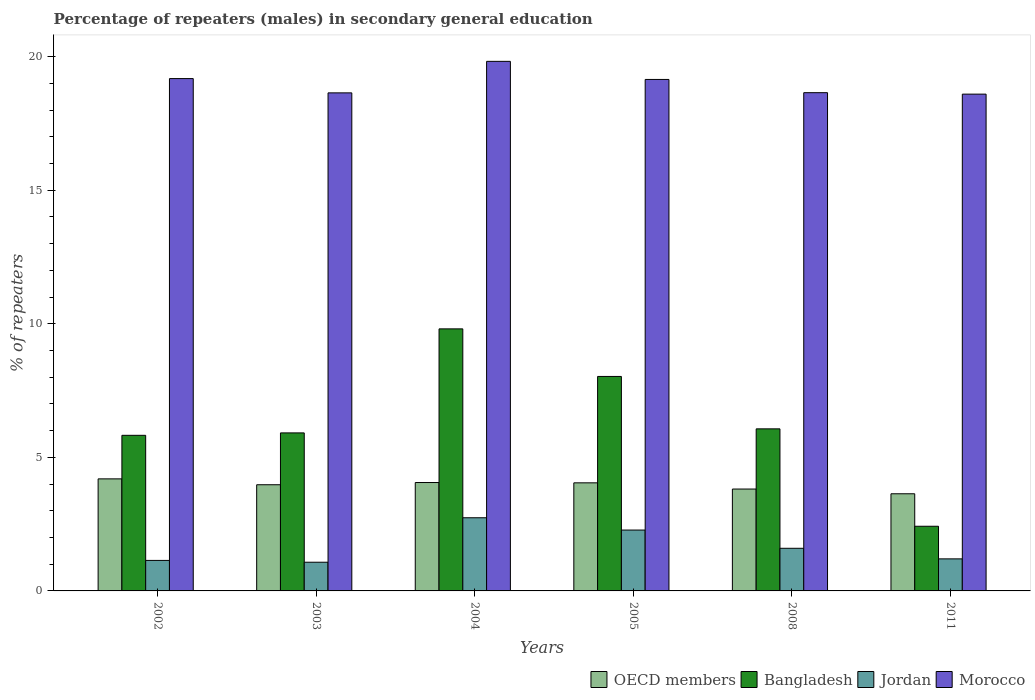How many groups of bars are there?
Give a very brief answer. 6. Are the number of bars per tick equal to the number of legend labels?
Keep it short and to the point. Yes. Are the number of bars on each tick of the X-axis equal?
Keep it short and to the point. Yes. How many bars are there on the 3rd tick from the left?
Provide a succinct answer. 4. What is the label of the 2nd group of bars from the left?
Offer a terse response. 2003. What is the percentage of male repeaters in OECD members in 2011?
Give a very brief answer. 3.64. Across all years, what is the maximum percentage of male repeaters in Morocco?
Your answer should be compact. 19.82. Across all years, what is the minimum percentage of male repeaters in Morocco?
Provide a succinct answer. 18.6. What is the total percentage of male repeaters in Bangladesh in the graph?
Provide a short and direct response. 38.07. What is the difference between the percentage of male repeaters in OECD members in 2002 and that in 2008?
Give a very brief answer. 0.38. What is the difference between the percentage of male repeaters in OECD members in 2003 and the percentage of male repeaters in Morocco in 2002?
Keep it short and to the point. -15.2. What is the average percentage of male repeaters in Morocco per year?
Make the answer very short. 19.01. In the year 2002, what is the difference between the percentage of male repeaters in OECD members and percentage of male repeaters in Morocco?
Offer a terse response. -14.98. What is the ratio of the percentage of male repeaters in Morocco in 2004 to that in 2005?
Offer a very short reply. 1.04. Is the difference between the percentage of male repeaters in OECD members in 2002 and 2008 greater than the difference between the percentage of male repeaters in Morocco in 2002 and 2008?
Provide a succinct answer. No. What is the difference between the highest and the second highest percentage of male repeaters in OECD members?
Offer a very short reply. 0.14. What is the difference between the highest and the lowest percentage of male repeaters in Jordan?
Your response must be concise. 1.66. In how many years, is the percentage of male repeaters in OECD members greater than the average percentage of male repeaters in OECD members taken over all years?
Keep it short and to the point. 4. Is the sum of the percentage of male repeaters in Jordan in 2008 and 2011 greater than the maximum percentage of male repeaters in OECD members across all years?
Offer a very short reply. No. What is the difference between two consecutive major ticks on the Y-axis?
Your answer should be compact. 5. Does the graph contain grids?
Keep it short and to the point. No. Where does the legend appear in the graph?
Provide a short and direct response. Bottom right. How many legend labels are there?
Provide a short and direct response. 4. What is the title of the graph?
Your answer should be very brief. Percentage of repeaters (males) in secondary general education. What is the label or title of the X-axis?
Provide a short and direct response. Years. What is the label or title of the Y-axis?
Give a very brief answer. % of repeaters. What is the % of repeaters in OECD members in 2002?
Your response must be concise. 4.19. What is the % of repeaters of Bangladesh in 2002?
Keep it short and to the point. 5.82. What is the % of repeaters in Jordan in 2002?
Provide a succinct answer. 1.14. What is the % of repeaters in Morocco in 2002?
Give a very brief answer. 19.18. What is the % of repeaters in OECD members in 2003?
Provide a short and direct response. 3.97. What is the % of repeaters in Bangladesh in 2003?
Offer a terse response. 5.92. What is the % of repeaters of Jordan in 2003?
Keep it short and to the point. 1.07. What is the % of repeaters of Morocco in 2003?
Make the answer very short. 18.64. What is the % of repeaters of OECD members in 2004?
Your response must be concise. 4.06. What is the % of repeaters of Bangladesh in 2004?
Offer a very short reply. 9.81. What is the % of repeaters of Jordan in 2004?
Your response must be concise. 2.74. What is the % of repeaters in Morocco in 2004?
Your answer should be compact. 19.82. What is the % of repeaters of OECD members in 2005?
Ensure brevity in your answer.  4.05. What is the % of repeaters in Bangladesh in 2005?
Your answer should be very brief. 8.03. What is the % of repeaters in Jordan in 2005?
Offer a terse response. 2.28. What is the % of repeaters of Morocco in 2005?
Provide a short and direct response. 19.15. What is the % of repeaters in OECD members in 2008?
Ensure brevity in your answer.  3.81. What is the % of repeaters of Bangladesh in 2008?
Provide a short and direct response. 6.07. What is the % of repeaters in Jordan in 2008?
Your answer should be very brief. 1.6. What is the % of repeaters in Morocco in 2008?
Offer a terse response. 18.65. What is the % of repeaters in OECD members in 2011?
Give a very brief answer. 3.64. What is the % of repeaters in Bangladesh in 2011?
Keep it short and to the point. 2.42. What is the % of repeaters of Jordan in 2011?
Keep it short and to the point. 1.2. What is the % of repeaters of Morocco in 2011?
Give a very brief answer. 18.6. Across all years, what is the maximum % of repeaters of OECD members?
Your response must be concise. 4.19. Across all years, what is the maximum % of repeaters of Bangladesh?
Make the answer very short. 9.81. Across all years, what is the maximum % of repeaters of Jordan?
Make the answer very short. 2.74. Across all years, what is the maximum % of repeaters of Morocco?
Give a very brief answer. 19.82. Across all years, what is the minimum % of repeaters in OECD members?
Make the answer very short. 3.64. Across all years, what is the minimum % of repeaters of Bangladesh?
Offer a terse response. 2.42. Across all years, what is the minimum % of repeaters in Jordan?
Provide a succinct answer. 1.07. Across all years, what is the minimum % of repeaters in Morocco?
Keep it short and to the point. 18.6. What is the total % of repeaters in OECD members in the graph?
Provide a succinct answer. 23.72. What is the total % of repeaters of Bangladesh in the graph?
Offer a very short reply. 38.07. What is the total % of repeaters of Jordan in the graph?
Provide a short and direct response. 10.03. What is the total % of repeaters of Morocco in the graph?
Keep it short and to the point. 114.04. What is the difference between the % of repeaters of OECD members in 2002 and that in 2003?
Your answer should be very brief. 0.22. What is the difference between the % of repeaters in Bangladesh in 2002 and that in 2003?
Give a very brief answer. -0.09. What is the difference between the % of repeaters in Jordan in 2002 and that in 2003?
Your response must be concise. 0.07. What is the difference between the % of repeaters in Morocco in 2002 and that in 2003?
Your response must be concise. 0.53. What is the difference between the % of repeaters in OECD members in 2002 and that in 2004?
Your answer should be compact. 0.14. What is the difference between the % of repeaters in Bangladesh in 2002 and that in 2004?
Provide a short and direct response. -3.98. What is the difference between the % of repeaters of Jordan in 2002 and that in 2004?
Your response must be concise. -1.6. What is the difference between the % of repeaters in Morocco in 2002 and that in 2004?
Ensure brevity in your answer.  -0.65. What is the difference between the % of repeaters in OECD members in 2002 and that in 2005?
Your answer should be compact. 0.15. What is the difference between the % of repeaters in Bangladesh in 2002 and that in 2005?
Make the answer very short. -2.2. What is the difference between the % of repeaters in Jordan in 2002 and that in 2005?
Your answer should be compact. -1.14. What is the difference between the % of repeaters of Morocco in 2002 and that in 2005?
Ensure brevity in your answer.  0.03. What is the difference between the % of repeaters in OECD members in 2002 and that in 2008?
Offer a very short reply. 0.38. What is the difference between the % of repeaters of Bangladesh in 2002 and that in 2008?
Your answer should be very brief. -0.24. What is the difference between the % of repeaters of Jordan in 2002 and that in 2008?
Your response must be concise. -0.45. What is the difference between the % of repeaters of Morocco in 2002 and that in 2008?
Give a very brief answer. 0.53. What is the difference between the % of repeaters of OECD members in 2002 and that in 2011?
Make the answer very short. 0.56. What is the difference between the % of repeaters of Bangladesh in 2002 and that in 2011?
Make the answer very short. 3.4. What is the difference between the % of repeaters of Jordan in 2002 and that in 2011?
Your answer should be very brief. -0.06. What is the difference between the % of repeaters in Morocco in 2002 and that in 2011?
Ensure brevity in your answer.  0.58. What is the difference between the % of repeaters in OECD members in 2003 and that in 2004?
Give a very brief answer. -0.08. What is the difference between the % of repeaters of Bangladesh in 2003 and that in 2004?
Your answer should be compact. -3.89. What is the difference between the % of repeaters in Jordan in 2003 and that in 2004?
Your answer should be compact. -1.66. What is the difference between the % of repeaters of Morocco in 2003 and that in 2004?
Give a very brief answer. -1.18. What is the difference between the % of repeaters of OECD members in 2003 and that in 2005?
Ensure brevity in your answer.  -0.07. What is the difference between the % of repeaters in Bangladesh in 2003 and that in 2005?
Your answer should be compact. -2.11. What is the difference between the % of repeaters in Jordan in 2003 and that in 2005?
Your answer should be compact. -1.2. What is the difference between the % of repeaters of Morocco in 2003 and that in 2005?
Ensure brevity in your answer.  -0.5. What is the difference between the % of repeaters of OECD members in 2003 and that in 2008?
Your answer should be compact. 0.16. What is the difference between the % of repeaters in Bangladesh in 2003 and that in 2008?
Your answer should be very brief. -0.15. What is the difference between the % of repeaters in Jordan in 2003 and that in 2008?
Provide a succinct answer. -0.52. What is the difference between the % of repeaters of Morocco in 2003 and that in 2008?
Provide a short and direct response. -0.01. What is the difference between the % of repeaters in OECD members in 2003 and that in 2011?
Give a very brief answer. 0.34. What is the difference between the % of repeaters of Bangladesh in 2003 and that in 2011?
Keep it short and to the point. 3.5. What is the difference between the % of repeaters of Jordan in 2003 and that in 2011?
Make the answer very short. -0.13. What is the difference between the % of repeaters of Morocco in 2003 and that in 2011?
Your answer should be compact. 0.05. What is the difference between the % of repeaters of OECD members in 2004 and that in 2005?
Your answer should be very brief. 0.01. What is the difference between the % of repeaters in Bangladesh in 2004 and that in 2005?
Ensure brevity in your answer.  1.78. What is the difference between the % of repeaters of Jordan in 2004 and that in 2005?
Keep it short and to the point. 0.46. What is the difference between the % of repeaters of Morocco in 2004 and that in 2005?
Your response must be concise. 0.68. What is the difference between the % of repeaters of OECD members in 2004 and that in 2008?
Ensure brevity in your answer.  0.24. What is the difference between the % of repeaters of Bangladesh in 2004 and that in 2008?
Your response must be concise. 3.74. What is the difference between the % of repeaters in Jordan in 2004 and that in 2008?
Keep it short and to the point. 1.14. What is the difference between the % of repeaters in Morocco in 2004 and that in 2008?
Provide a short and direct response. 1.17. What is the difference between the % of repeaters in OECD members in 2004 and that in 2011?
Give a very brief answer. 0.42. What is the difference between the % of repeaters in Bangladesh in 2004 and that in 2011?
Provide a succinct answer. 7.39. What is the difference between the % of repeaters of Jordan in 2004 and that in 2011?
Give a very brief answer. 1.54. What is the difference between the % of repeaters in Morocco in 2004 and that in 2011?
Offer a terse response. 1.23. What is the difference between the % of repeaters of OECD members in 2005 and that in 2008?
Offer a terse response. 0.23. What is the difference between the % of repeaters of Bangladesh in 2005 and that in 2008?
Provide a succinct answer. 1.96. What is the difference between the % of repeaters of Jordan in 2005 and that in 2008?
Make the answer very short. 0.68. What is the difference between the % of repeaters in Morocco in 2005 and that in 2008?
Give a very brief answer. 0.5. What is the difference between the % of repeaters of OECD members in 2005 and that in 2011?
Your answer should be very brief. 0.41. What is the difference between the % of repeaters in Bangladesh in 2005 and that in 2011?
Your answer should be compact. 5.61. What is the difference between the % of repeaters in Jordan in 2005 and that in 2011?
Your answer should be very brief. 1.08. What is the difference between the % of repeaters of Morocco in 2005 and that in 2011?
Your answer should be compact. 0.55. What is the difference between the % of repeaters of OECD members in 2008 and that in 2011?
Keep it short and to the point. 0.18. What is the difference between the % of repeaters in Bangladesh in 2008 and that in 2011?
Your answer should be compact. 3.65. What is the difference between the % of repeaters in Jordan in 2008 and that in 2011?
Your answer should be compact. 0.4. What is the difference between the % of repeaters in Morocco in 2008 and that in 2011?
Give a very brief answer. 0.05. What is the difference between the % of repeaters in OECD members in 2002 and the % of repeaters in Bangladesh in 2003?
Ensure brevity in your answer.  -1.72. What is the difference between the % of repeaters of OECD members in 2002 and the % of repeaters of Jordan in 2003?
Keep it short and to the point. 3.12. What is the difference between the % of repeaters of OECD members in 2002 and the % of repeaters of Morocco in 2003?
Provide a short and direct response. -14.45. What is the difference between the % of repeaters in Bangladesh in 2002 and the % of repeaters in Jordan in 2003?
Your answer should be very brief. 4.75. What is the difference between the % of repeaters of Bangladesh in 2002 and the % of repeaters of Morocco in 2003?
Offer a very short reply. -12.82. What is the difference between the % of repeaters of Jordan in 2002 and the % of repeaters of Morocco in 2003?
Your answer should be very brief. -17.5. What is the difference between the % of repeaters of OECD members in 2002 and the % of repeaters of Bangladesh in 2004?
Provide a short and direct response. -5.61. What is the difference between the % of repeaters of OECD members in 2002 and the % of repeaters of Jordan in 2004?
Your response must be concise. 1.46. What is the difference between the % of repeaters in OECD members in 2002 and the % of repeaters in Morocco in 2004?
Your response must be concise. -15.63. What is the difference between the % of repeaters of Bangladesh in 2002 and the % of repeaters of Jordan in 2004?
Offer a terse response. 3.09. What is the difference between the % of repeaters of Bangladesh in 2002 and the % of repeaters of Morocco in 2004?
Offer a very short reply. -14. What is the difference between the % of repeaters in Jordan in 2002 and the % of repeaters in Morocco in 2004?
Keep it short and to the point. -18.68. What is the difference between the % of repeaters of OECD members in 2002 and the % of repeaters of Bangladesh in 2005?
Offer a very short reply. -3.83. What is the difference between the % of repeaters of OECD members in 2002 and the % of repeaters of Jordan in 2005?
Your answer should be very brief. 1.92. What is the difference between the % of repeaters of OECD members in 2002 and the % of repeaters of Morocco in 2005?
Provide a succinct answer. -14.95. What is the difference between the % of repeaters of Bangladesh in 2002 and the % of repeaters of Jordan in 2005?
Give a very brief answer. 3.55. What is the difference between the % of repeaters in Bangladesh in 2002 and the % of repeaters in Morocco in 2005?
Keep it short and to the point. -13.32. What is the difference between the % of repeaters in Jordan in 2002 and the % of repeaters in Morocco in 2005?
Provide a succinct answer. -18. What is the difference between the % of repeaters in OECD members in 2002 and the % of repeaters in Bangladesh in 2008?
Your answer should be very brief. -1.87. What is the difference between the % of repeaters in OECD members in 2002 and the % of repeaters in Jordan in 2008?
Your answer should be compact. 2.6. What is the difference between the % of repeaters of OECD members in 2002 and the % of repeaters of Morocco in 2008?
Your answer should be compact. -14.46. What is the difference between the % of repeaters in Bangladesh in 2002 and the % of repeaters in Jordan in 2008?
Your answer should be compact. 4.23. What is the difference between the % of repeaters of Bangladesh in 2002 and the % of repeaters of Morocco in 2008?
Offer a terse response. -12.83. What is the difference between the % of repeaters in Jordan in 2002 and the % of repeaters in Morocco in 2008?
Provide a short and direct response. -17.51. What is the difference between the % of repeaters in OECD members in 2002 and the % of repeaters in Bangladesh in 2011?
Offer a terse response. 1.77. What is the difference between the % of repeaters of OECD members in 2002 and the % of repeaters of Jordan in 2011?
Offer a terse response. 3. What is the difference between the % of repeaters in OECD members in 2002 and the % of repeaters in Morocco in 2011?
Provide a succinct answer. -14.4. What is the difference between the % of repeaters of Bangladesh in 2002 and the % of repeaters of Jordan in 2011?
Make the answer very short. 4.63. What is the difference between the % of repeaters in Bangladesh in 2002 and the % of repeaters in Morocco in 2011?
Your answer should be very brief. -12.77. What is the difference between the % of repeaters in Jordan in 2002 and the % of repeaters in Morocco in 2011?
Provide a short and direct response. -17.46. What is the difference between the % of repeaters in OECD members in 2003 and the % of repeaters in Bangladesh in 2004?
Provide a succinct answer. -5.83. What is the difference between the % of repeaters in OECD members in 2003 and the % of repeaters in Jordan in 2004?
Your response must be concise. 1.24. What is the difference between the % of repeaters of OECD members in 2003 and the % of repeaters of Morocco in 2004?
Ensure brevity in your answer.  -15.85. What is the difference between the % of repeaters in Bangladesh in 2003 and the % of repeaters in Jordan in 2004?
Keep it short and to the point. 3.18. What is the difference between the % of repeaters in Bangladesh in 2003 and the % of repeaters in Morocco in 2004?
Your answer should be very brief. -13.91. What is the difference between the % of repeaters of Jordan in 2003 and the % of repeaters of Morocco in 2004?
Give a very brief answer. -18.75. What is the difference between the % of repeaters of OECD members in 2003 and the % of repeaters of Bangladesh in 2005?
Provide a short and direct response. -4.05. What is the difference between the % of repeaters of OECD members in 2003 and the % of repeaters of Jordan in 2005?
Your response must be concise. 1.7. What is the difference between the % of repeaters in OECD members in 2003 and the % of repeaters in Morocco in 2005?
Offer a very short reply. -15.17. What is the difference between the % of repeaters of Bangladesh in 2003 and the % of repeaters of Jordan in 2005?
Make the answer very short. 3.64. What is the difference between the % of repeaters of Bangladesh in 2003 and the % of repeaters of Morocco in 2005?
Provide a succinct answer. -13.23. What is the difference between the % of repeaters of Jordan in 2003 and the % of repeaters of Morocco in 2005?
Provide a short and direct response. -18.07. What is the difference between the % of repeaters of OECD members in 2003 and the % of repeaters of Bangladesh in 2008?
Your answer should be very brief. -2.09. What is the difference between the % of repeaters of OECD members in 2003 and the % of repeaters of Jordan in 2008?
Your response must be concise. 2.38. What is the difference between the % of repeaters in OECD members in 2003 and the % of repeaters in Morocco in 2008?
Your response must be concise. -14.68. What is the difference between the % of repeaters of Bangladesh in 2003 and the % of repeaters of Jordan in 2008?
Provide a short and direct response. 4.32. What is the difference between the % of repeaters in Bangladesh in 2003 and the % of repeaters in Morocco in 2008?
Offer a terse response. -12.74. What is the difference between the % of repeaters of Jordan in 2003 and the % of repeaters of Morocco in 2008?
Your answer should be very brief. -17.58. What is the difference between the % of repeaters in OECD members in 2003 and the % of repeaters in Bangladesh in 2011?
Offer a terse response. 1.55. What is the difference between the % of repeaters in OECD members in 2003 and the % of repeaters in Jordan in 2011?
Your response must be concise. 2.78. What is the difference between the % of repeaters of OECD members in 2003 and the % of repeaters of Morocco in 2011?
Offer a very short reply. -14.62. What is the difference between the % of repeaters in Bangladesh in 2003 and the % of repeaters in Jordan in 2011?
Your answer should be very brief. 4.72. What is the difference between the % of repeaters of Bangladesh in 2003 and the % of repeaters of Morocco in 2011?
Your answer should be compact. -12.68. What is the difference between the % of repeaters in Jordan in 2003 and the % of repeaters in Morocco in 2011?
Ensure brevity in your answer.  -17.52. What is the difference between the % of repeaters of OECD members in 2004 and the % of repeaters of Bangladesh in 2005?
Give a very brief answer. -3.97. What is the difference between the % of repeaters in OECD members in 2004 and the % of repeaters in Jordan in 2005?
Provide a succinct answer. 1.78. What is the difference between the % of repeaters of OECD members in 2004 and the % of repeaters of Morocco in 2005?
Provide a short and direct response. -15.09. What is the difference between the % of repeaters in Bangladesh in 2004 and the % of repeaters in Jordan in 2005?
Offer a terse response. 7.53. What is the difference between the % of repeaters in Bangladesh in 2004 and the % of repeaters in Morocco in 2005?
Your answer should be very brief. -9.34. What is the difference between the % of repeaters in Jordan in 2004 and the % of repeaters in Morocco in 2005?
Your answer should be very brief. -16.41. What is the difference between the % of repeaters of OECD members in 2004 and the % of repeaters of Bangladesh in 2008?
Keep it short and to the point. -2.01. What is the difference between the % of repeaters in OECD members in 2004 and the % of repeaters in Jordan in 2008?
Keep it short and to the point. 2.46. What is the difference between the % of repeaters of OECD members in 2004 and the % of repeaters of Morocco in 2008?
Your answer should be compact. -14.59. What is the difference between the % of repeaters of Bangladesh in 2004 and the % of repeaters of Jordan in 2008?
Offer a very short reply. 8.21. What is the difference between the % of repeaters of Bangladesh in 2004 and the % of repeaters of Morocco in 2008?
Give a very brief answer. -8.84. What is the difference between the % of repeaters of Jordan in 2004 and the % of repeaters of Morocco in 2008?
Keep it short and to the point. -15.91. What is the difference between the % of repeaters of OECD members in 2004 and the % of repeaters of Bangladesh in 2011?
Offer a very short reply. 1.64. What is the difference between the % of repeaters of OECD members in 2004 and the % of repeaters of Jordan in 2011?
Your answer should be compact. 2.86. What is the difference between the % of repeaters of OECD members in 2004 and the % of repeaters of Morocco in 2011?
Make the answer very short. -14.54. What is the difference between the % of repeaters of Bangladesh in 2004 and the % of repeaters of Jordan in 2011?
Keep it short and to the point. 8.61. What is the difference between the % of repeaters in Bangladesh in 2004 and the % of repeaters in Morocco in 2011?
Offer a very short reply. -8.79. What is the difference between the % of repeaters in Jordan in 2004 and the % of repeaters in Morocco in 2011?
Make the answer very short. -15.86. What is the difference between the % of repeaters in OECD members in 2005 and the % of repeaters in Bangladesh in 2008?
Offer a very short reply. -2.02. What is the difference between the % of repeaters of OECD members in 2005 and the % of repeaters of Jordan in 2008?
Offer a very short reply. 2.45. What is the difference between the % of repeaters of OECD members in 2005 and the % of repeaters of Morocco in 2008?
Make the answer very short. -14.6. What is the difference between the % of repeaters in Bangladesh in 2005 and the % of repeaters in Jordan in 2008?
Keep it short and to the point. 6.43. What is the difference between the % of repeaters of Bangladesh in 2005 and the % of repeaters of Morocco in 2008?
Keep it short and to the point. -10.62. What is the difference between the % of repeaters in Jordan in 2005 and the % of repeaters in Morocco in 2008?
Your response must be concise. -16.37. What is the difference between the % of repeaters in OECD members in 2005 and the % of repeaters in Bangladesh in 2011?
Your answer should be very brief. 1.63. What is the difference between the % of repeaters in OECD members in 2005 and the % of repeaters in Jordan in 2011?
Ensure brevity in your answer.  2.85. What is the difference between the % of repeaters of OECD members in 2005 and the % of repeaters of Morocco in 2011?
Your answer should be very brief. -14.55. What is the difference between the % of repeaters in Bangladesh in 2005 and the % of repeaters in Jordan in 2011?
Provide a short and direct response. 6.83. What is the difference between the % of repeaters in Bangladesh in 2005 and the % of repeaters in Morocco in 2011?
Your response must be concise. -10.57. What is the difference between the % of repeaters of Jordan in 2005 and the % of repeaters of Morocco in 2011?
Make the answer very short. -16.32. What is the difference between the % of repeaters of OECD members in 2008 and the % of repeaters of Bangladesh in 2011?
Provide a short and direct response. 1.39. What is the difference between the % of repeaters of OECD members in 2008 and the % of repeaters of Jordan in 2011?
Your answer should be compact. 2.61. What is the difference between the % of repeaters in OECD members in 2008 and the % of repeaters in Morocco in 2011?
Make the answer very short. -14.78. What is the difference between the % of repeaters in Bangladesh in 2008 and the % of repeaters in Jordan in 2011?
Give a very brief answer. 4.87. What is the difference between the % of repeaters in Bangladesh in 2008 and the % of repeaters in Morocco in 2011?
Your answer should be very brief. -12.53. What is the difference between the % of repeaters of Jordan in 2008 and the % of repeaters of Morocco in 2011?
Provide a short and direct response. -17. What is the average % of repeaters in OECD members per year?
Make the answer very short. 3.95. What is the average % of repeaters in Bangladesh per year?
Provide a short and direct response. 6.34. What is the average % of repeaters of Jordan per year?
Ensure brevity in your answer.  1.67. What is the average % of repeaters in Morocco per year?
Keep it short and to the point. 19.01. In the year 2002, what is the difference between the % of repeaters in OECD members and % of repeaters in Bangladesh?
Offer a very short reply. -1.63. In the year 2002, what is the difference between the % of repeaters in OECD members and % of repeaters in Jordan?
Keep it short and to the point. 3.05. In the year 2002, what is the difference between the % of repeaters in OECD members and % of repeaters in Morocco?
Give a very brief answer. -14.98. In the year 2002, what is the difference between the % of repeaters of Bangladesh and % of repeaters of Jordan?
Provide a short and direct response. 4.68. In the year 2002, what is the difference between the % of repeaters in Bangladesh and % of repeaters in Morocco?
Offer a terse response. -13.35. In the year 2002, what is the difference between the % of repeaters in Jordan and % of repeaters in Morocco?
Offer a terse response. -18.04. In the year 2003, what is the difference between the % of repeaters in OECD members and % of repeaters in Bangladesh?
Make the answer very short. -1.94. In the year 2003, what is the difference between the % of repeaters in OECD members and % of repeaters in Jordan?
Make the answer very short. 2.9. In the year 2003, what is the difference between the % of repeaters of OECD members and % of repeaters of Morocco?
Provide a short and direct response. -14.67. In the year 2003, what is the difference between the % of repeaters of Bangladesh and % of repeaters of Jordan?
Your answer should be compact. 4.84. In the year 2003, what is the difference between the % of repeaters of Bangladesh and % of repeaters of Morocco?
Your answer should be compact. -12.73. In the year 2003, what is the difference between the % of repeaters of Jordan and % of repeaters of Morocco?
Offer a very short reply. -17.57. In the year 2004, what is the difference between the % of repeaters of OECD members and % of repeaters of Bangladesh?
Your answer should be compact. -5.75. In the year 2004, what is the difference between the % of repeaters in OECD members and % of repeaters in Jordan?
Keep it short and to the point. 1.32. In the year 2004, what is the difference between the % of repeaters in OECD members and % of repeaters in Morocco?
Keep it short and to the point. -15.77. In the year 2004, what is the difference between the % of repeaters of Bangladesh and % of repeaters of Jordan?
Give a very brief answer. 7.07. In the year 2004, what is the difference between the % of repeaters of Bangladesh and % of repeaters of Morocco?
Make the answer very short. -10.01. In the year 2004, what is the difference between the % of repeaters in Jordan and % of repeaters in Morocco?
Ensure brevity in your answer.  -17.09. In the year 2005, what is the difference between the % of repeaters in OECD members and % of repeaters in Bangladesh?
Your answer should be very brief. -3.98. In the year 2005, what is the difference between the % of repeaters in OECD members and % of repeaters in Jordan?
Offer a terse response. 1.77. In the year 2005, what is the difference between the % of repeaters of OECD members and % of repeaters of Morocco?
Offer a terse response. -15.1. In the year 2005, what is the difference between the % of repeaters of Bangladesh and % of repeaters of Jordan?
Provide a succinct answer. 5.75. In the year 2005, what is the difference between the % of repeaters in Bangladesh and % of repeaters in Morocco?
Make the answer very short. -11.12. In the year 2005, what is the difference between the % of repeaters in Jordan and % of repeaters in Morocco?
Your answer should be compact. -16.87. In the year 2008, what is the difference between the % of repeaters of OECD members and % of repeaters of Bangladesh?
Keep it short and to the point. -2.25. In the year 2008, what is the difference between the % of repeaters of OECD members and % of repeaters of Jordan?
Provide a succinct answer. 2.22. In the year 2008, what is the difference between the % of repeaters of OECD members and % of repeaters of Morocco?
Keep it short and to the point. -14.84. In the year 2008, what is the difference between the % of repeaters of Bangladesh and % of repeaters of Jordan?
Make the answer very short. 4.47. In the year 2008, what is the difference between the % of repeaters of Bangladesh and % of repeaters of Morocco?
Make the answer very short. -12.58. In the year 2008, what is the difference between the % of repeaters in Jordan and % of repeaters in Morocco?
Your answer should be compact. -17.06. In the year 2011, what is the difference between the % of repeaters of OECD members and % of repeaters of Bangladesh?
Offer a terse response. 1.22. In the year 2011, what is the difference between the % of repeaters in OECD members and % of repeaters in Jordan?
Your answer should be very brief. 2.44. In the year 2011, what is the difference between the % of repeaters of OECD members and % of repeaters of Morocco?
Keep it short and to the point. -14.96. In the year 2011, what is the difference between the % of repeaters of Bangladesh and % of repeaters of Jordan?
Your answer should be very brief. 1.22. In the year 2011, what is the difference between the % of repeaters in Bangladesh and % of repeaters in Morocco?
Make the answer very short. -16.18. In the year 2011, what is the difference between the % of repeaters in Jordan and % of repeaters in Morocco?
Your response must be concise. -17.4. What is the ratio of the % of repeaters of OECD members in 2002 to that in 2003?
Ensure brevity in your answer.  1.06. What is the ratio of the % of repeaters in Bangladesh in 2002 to that in 2003?
Keep it short and to the point. 0.98. What is the ratio of the % of repeaters in Jordan in 2002 to that in 2003?
Your answer should be compact. 1.06. What is the ratio of the % of repeaters in Morocco in 2002 to that in 2003?
Offer a terse response. 1.03. What is the ratio of the % of repeaters of OECD members in 2002 to that in 2004?
Keep it short and to the point. 1.03. What is the ratio of the % of repeaters in Bangladesh in 2002 to that in 2004?
Give a very brief answer. 0.59. What is the ratio of the % of repeaters in Jordan in 2002 to that in 2004?
Your answer should be very brief. 0.42. What is the ratio of the % of repeaters in Morocco in 2002 to that in 2004?
Your answer should be very brief. 0.97. What is the ratio of the % of repeaters of OECD members in 2002 to that in 2005?
Your answer should be compact. 1.04. What is the ratio of the % of repeaters of Bangladesh in 2002 to that in 2005?
Your answer should be compact. 0.73. What is the ratio of the % of repeaters in Jordan in 2002 to that in 2005?
Ensure brevity in your answer.  0.5. What is the ratio of the % of repeaters of Morocco in 2002 to that in 2005?
Your response must be concise. 1. What is the ratio of the % of repeaters of Bangladesh in 2002 to that in 2008?
Make the answer very short. 0.96. What is the ratio of the % of repeaters of Jordan in 2002 to that in 2008?
Make the answer very short. 0.72. What is the ratio of the % of repeaters in Morocco in 2002 to that in 2008?
Your answer should be very brief. 1.03. What is the ratio of the % of repeaters in OECD members in 2002 to that in 2011?
Offer a terse response. 1.15. What is the ratio of the % of repeaters in Bangladesh in 2002 to that in 2011?
Make the answer very short. 2.41. What is the ratio of the % of repeaters of Jordan in 2002 to that in 2011?
Make the answer very short. 0.95. What is the ratio of the % of repeaters of Morocco in 2002 to that in 2011?
Make the answer very short. 1.03. What is the ratio of the % of repeaters of OECD members in 2003 to that in 2004?
Provide a short and direct response. 0.98. What is the ratio of the % of repeaters of Bangladesh in 2003 to that in 2004?
Give a very brief answer. 0.6. What is the ratio of the % of repeaters of Jordan in 2003 to that in 2004?
Provide a succinct answer. 0.39. What is the ratio of the % of repeaters in Morocco in 2003 to that in 2004?
Your answer should be very brief. 0.94. What is the ratio of the % of repeaters in OECD members in 2003 to that in 2005?
Your answer should be very brief. 0.98. What is the ratio of the % of repeaters of Bangladesh in 2003 to that in 2005?
Provide a short and direct response. 0.74. What is the ratio of the % of repeaters in Jordan in 2003 to that in 2005?
Provide a succinct answer. 0.47. What is the ratio of the % of repeaters in Morocco in 2003 to that in 2005?
Give a very brief answer. 0.97. What is the ratio of the % of repeaters of OECD members in 2003 to that in 2008?
Your answer should be compact. 1.04. What is the ratio of the % of repeaters in Bangladesh in 2003 to that in 2008?
Provide a succinct answer. 0.98. What is the ratio of the % of repeaters in Jordan in 2003 to that in 2008?
Offer a terse response. 0.67. What is the ratio of the % of repeaters in Morocco in 2003 to that in 2008?
Your answer should be very brief. 1. What is the ratio of the % of repeaters in OECD members in 2003 to that in 2011?
Provide a succinct answer. 1.09. What is the ratio of the % of repeaters of Bangladesh in 2003 to that in 2011?
Ensure brevity in your answer.  2.44. What is the ratio of the % of repeaters of Jordan in 2003 to that in 2011?
Offer a very short reply. 0.9. What is the ratio of the % of repeaters in Morocco in 2003 to that in 2011?
Offer a very short reply. 1. What is the ratio of the % of repeaters of Bangladesh in 2004 to that in 2005?
Make the answer very short. 1.22. What is the ratio of the % of repeaters of Jordan in 2004 to that in 2005?
Your response must be concise. 1.2. What is the ratio of the % of repeaters of Morocco in 2004 to that in 2005?
Make the answer very short. 1.04. What is the ratio of the % of repeaters of OECD members in 2004 to that in 2008?
Offer a terse response. 1.06. What is the ratio of the % of repeaters in Bangladesh in 2004 to that in 2008?
Make the answer very short. 1.62. What is the ratio of the % of repeaters in Jordan in 2004 to that in 2008?
Provide a short and direct response. 1.72. What is the ratio of the % of repeaters of Morocco in 2004 to that in 2008?
Your answer should be compact. 1.06. What is the ratio of the % of repeaters in OECD members in 2004 to that in 2011?
Provide a succinct answer. 1.12. What is the ratio of the % of repeaters in Bangladesh in 2004 to that in 2011?
Provide a succinct answer. 4.05. What is the ratio of the % of repeaters in Jordan in 2004 to that in 2011?
Provide a short and direct response. 2.28. What is the ratio of the % of repeaters in Morocco in 2004 to that in 2011?
Provide a succinct answer. 1.07. What is the ratio of the % of repeaters of OECD members in 2005 to that in 2008?
Keep it short and to the point. 1.06. What is the ratio of the % of repeaters of Bangladesh in 2005 to that in 2008?
Keep it short and to the point. 1.32. What is the ratio of the % of repeaters of Jordan in 2005 to that in 2008?
Provide a succinct answer. 1.43. What is the ratio of the % of repeaters of Morocco in 2005 to that in 2008?
Offer a very short reply. 1.03. What is the ratio of the % of repeaters of OECD members in 2005 to that in 2011?
Ensure brevity in your answer.  1.11. What is the ratio of the % of repeaters of Bangladesh in 2005 to that in 2011?
Your answer should be compact. 3.32. What is the ratio of the % of repeaters in Jordan in 2005 to that in 2011?
Your answer should be compact. 1.9. What is the ratio of the % of repeaters of Morocco in 2005 to that in 2011?
Your answer should be compact. 1.03. What is the ratio of the % of repeaters in OECD members in 2008 to that in 2011?
Provide a succinct answer. 1.05. What is the ratio of the % of repeaters of Bangladesh in 2008 to that in 2011?
Keep it short and to the point. 2.51. What is the ratio of the % of repeaters of Jordan in 2008 to that in 2011?
Your answer should be compact. 1.33. What is the difference between the highest and the second highest % of repeaters of OECD members?
Your answer should be compact. 0.14. What is the difference between the highest and the second highest % of repeaters of Bangladesh?
Offer a terse response. 1.78. What is the difference between the highest and the second highest % of repeaters in Jordan?
Keep it short and to the point. 0.46. What is the difference between the highest and the second highest % of repeaters in Morocco?
Offer a terse response. 0.65. What is the difference between the highest and the lowest % of repeaters of OECD members?
Ensure brevity in your answer.  0.56. What is the difference between the highest and the lowest % of repeaters in Bangladesh?
Make the answer very short. 7.39. What is the difference between the highest and the lowest % of repeaters in Jordan?
Ensure brevity in your answer.  1.66. What is the difference between the highest and the lowest % of repeaters in Morocco?
Offer a very short reply. 1.23. 